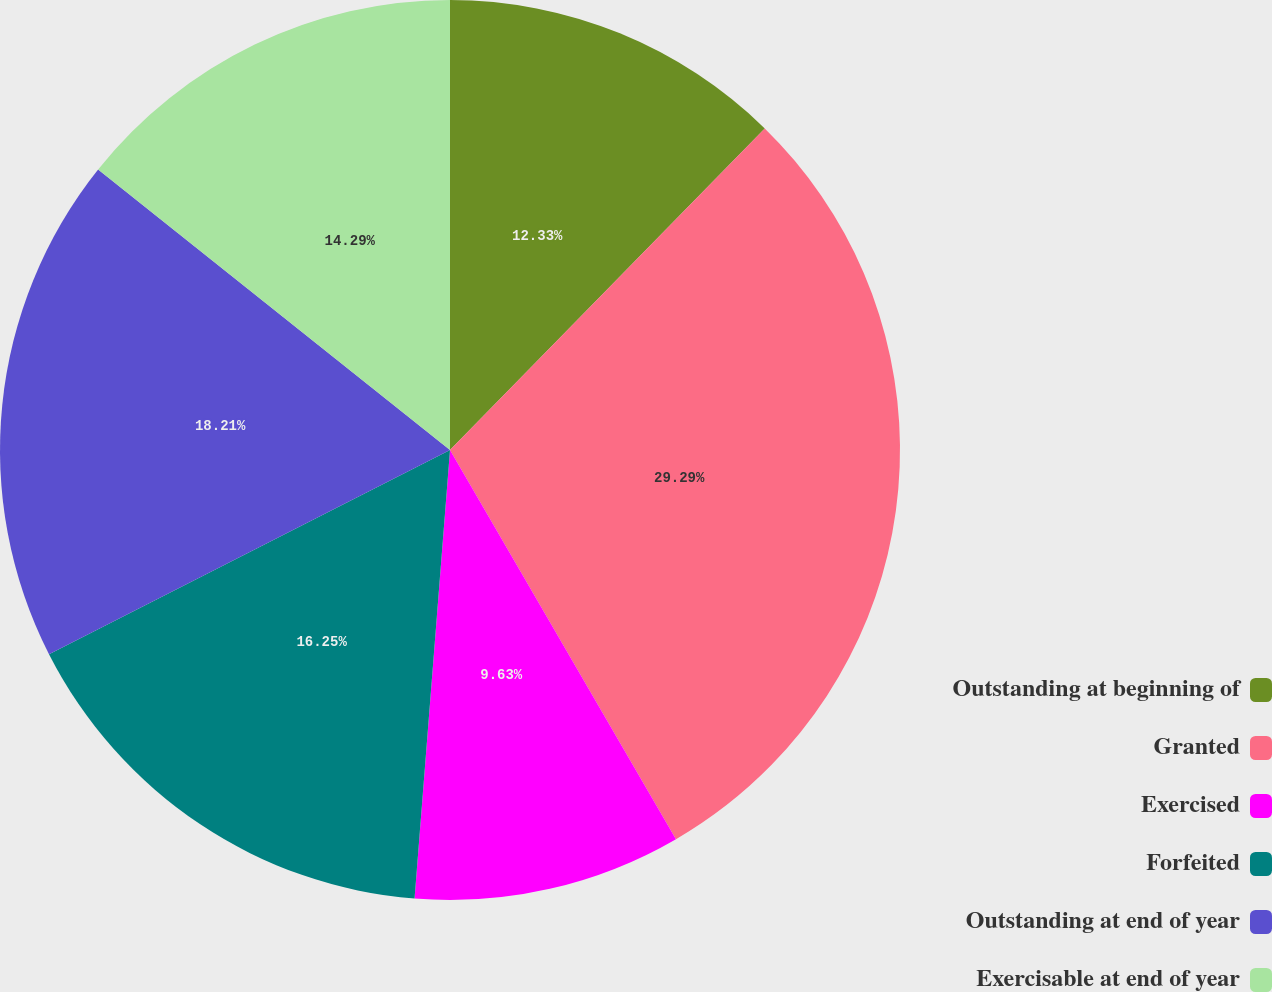Convert chart. <chart><loc_0><loc_0><loc_500><loc_500><pie_chart><fcel>Outstanding at beginning of<fcel>Granted<fcel>Exercised<fcel>Forfeited<fcel>Outstanding at end of year<fcel>Exercisable at end of year<nl><fcel>12.33%<fcel>29.3%<fcel>9.63%<fcel>16.25%<fcel>18.21%<fcel>14.29%<nl></chart> 